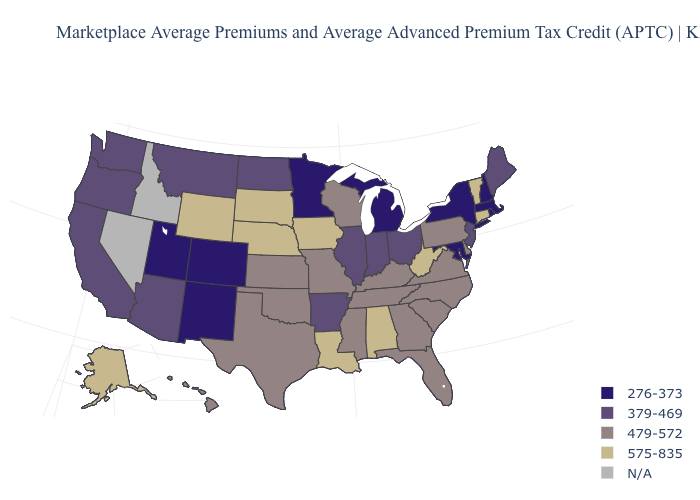Name the states that have a value in the range 276-373?
Give a very brief answer. Colorado, Maryland, Massachusetts, Michigan, Minnesota, New Hampshire, New Mexico, New York, Rhode Island, Utah. Name the states that have a value in the range N/A?
Quick response, please. Idaho, Nevada. Does the first symbol in the legend represent the smallest category?
Short answer required. Yes. What is the highest value in the MidWest ?
Give a very brief answer. 575-835. Does Vermont have the highest value in the USA?
Short answer required. Yes. Name the states that have a value in the range 575-835?
Concise answer only. Alabama, Alaska, Connecticut, Iowa, Louisiana, Nebraska, South Dakota, Vermont, West Virginia, Wyoming. Is the legend a continuous bar?
Write a very short answer. No. What is the value of Montana?
Keep it brief. 379-469. Does the map have missing data?
Keep it brief. Yes. What is the value of Virginia?
Quick response, please. 479-572. What is the value of Vermont?
Concise answer only. 575-835. Among the states that border Nebraska , does Iowa have the highest value?
Be succinct. Yes. Which states have the lowest value in the USA?
Write a very short answer. Colorado, Maryland, Massachusetts, Michigan, Minnesota, New Hampshire, New Mexico, New York, Rhode Island, Utah. What is the value of Kansas?
Quick response, please. 479-572. 